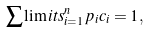Convert formula to latex. <formula><loc_0><loc_0><loc_500><loc_500>\sum \lim i t s _ { i = 1 } ^ { n } { p _ { i } c _ { i } = 1 } ,</formula> 